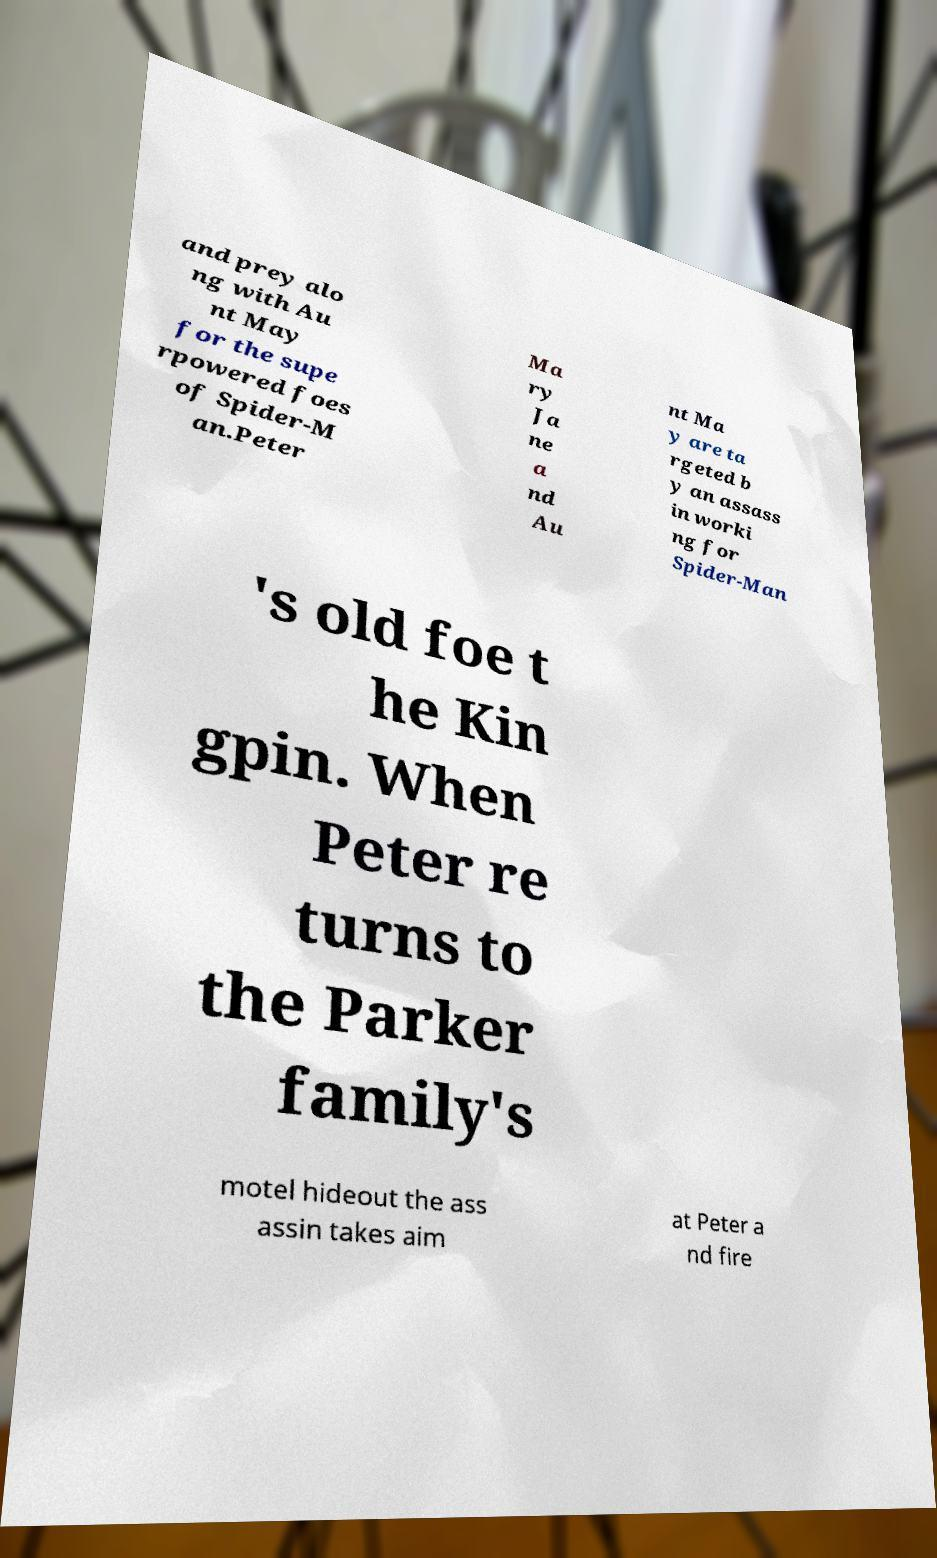Please identify and transcribe the text found in this image. and prey alo ng with Au nt May for the supe rpowered foes of Spider-M an.Peter Ma ry Ja ne a nd Au nt Ma y are ta rgeted b y an assass in worki ng for Spider-Man 's old foe t he Kin gpin. When Peter re turns to the Parker family's motel hideout the ass assin takes aim at Peter a nd fire 